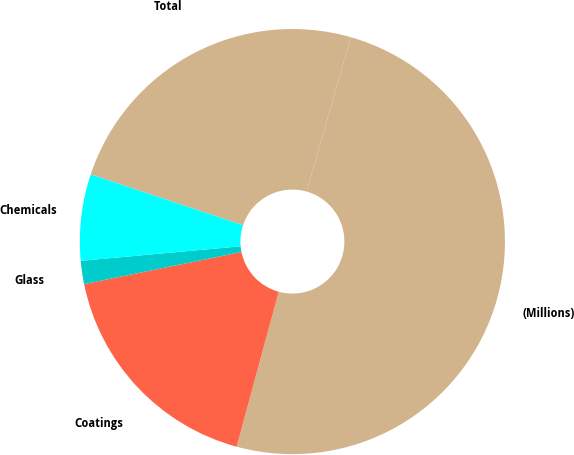Convert chart to OTSL. <chart><loc_0><loc_0><loc_500><loc_500><pie_chart><fcel>(Millions)<fcel>Coatings<fcel>Glass<fcel>Chemicals<fcel>Total<nl><fcel>49.79%<fcel>17.57%<fcel>1.76%<fcel>6.57%<fcel>24.31%<nl></chart> 